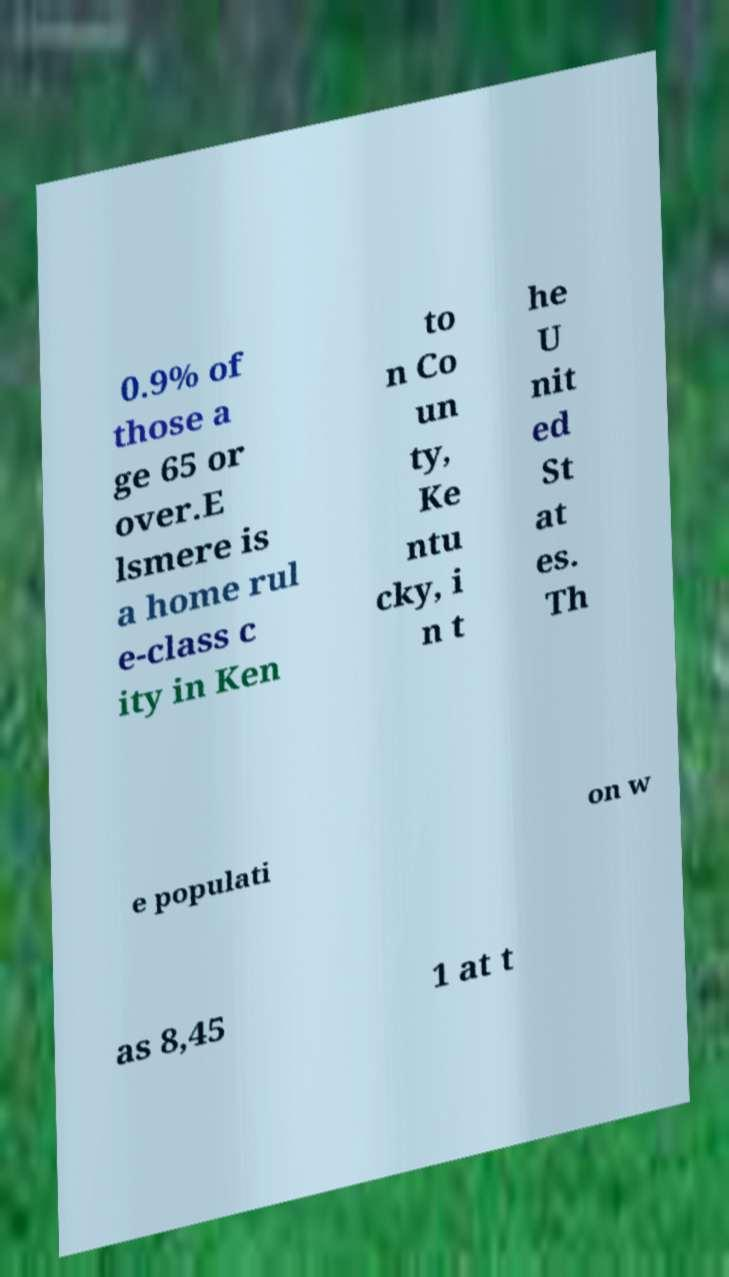There's text embedded in this image that I need extracted. Can you transcribe it verbatim? 0.9% of those a ge 65 or over.E lsmere is a home rul e-class c ity in Ken to n Co un ty, Ke ntu cky, i n t he U nit ed St at es. Th e populati on w as 8,45 1 at t 